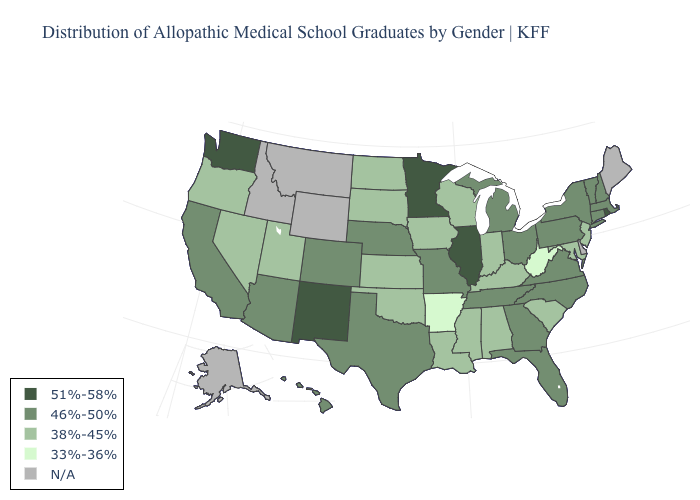Name the states that have a value in the range N/A?
Concise answer only. Alaska, Delaware, Idaho, Maine, Montana, Wyoming. What is the highest value in the USA?
Write a very short answer. 51%-58%. How many symbols are there in the legend?
Quick response, please. 5. Name the states that have a value in the range N/A?
Short answer required. Alaska, Delaware, Idaho, Maine, Montana, Wyoming. Which states have the highest value in the USA?
Short answer required. Illinois, Minnesota, New Mexico, Rhode Island, Washington. What is the highest value in the MidWest ?
Be succinct. 51%-58%. Among the states that border Indiana , does Michigan have the highest value?
Short answer required. No. What is the value of Virginia?
Answer briefly. 46%-50%. Does New Hampshire have the lowest value in the USA?
Keep it brief. No. Is the legend a continuous bar?
Write a very short answer. No. Name the states that have a value in the range 38%-45%?
Keep it brief. Alabama, Indiana, Iowa, Kansas, Kentucky, Louisiana, Maryland, Mississippi, Nevada, New Jersey, North Dakota, Oklahoma, Oregon, South Carolina, South Dakota, Utah, Wisconsin. Name the states that have a value in the range 33%-36%?
Answer briefly. Arkansas, West Virginia. Which states have the lowest value in the USA?
Write a very short answer. Arkansas, West Virginia. Name the states that have a value in the range 33%-36%?
Be succinct. Arkansas, West Virginia. 